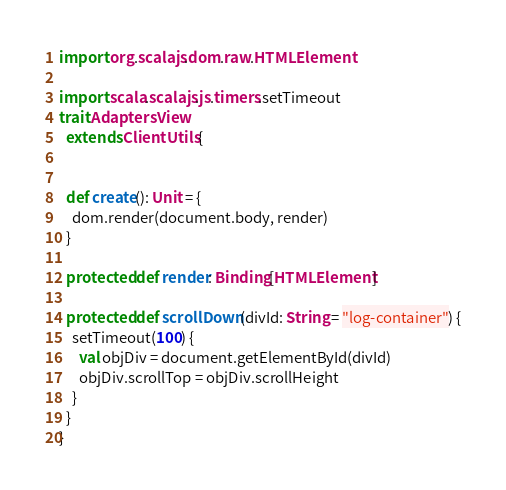Convert code to text. <code><loc_0><loc_0><loc_500><loc_500><_Scala_>import org.scalajs.dom.raw.HTMLElement

import scala.scalajs.js.timers.setTimeout
trait AdaptersView
  extends ClientUtils {


  def create(): Unit = {
    dom.render(document.body, render)
  }

  protected def render: Binding[HTMLElement]

  protected def scrollDown(divId: String = "log-container") {
    setTimeout(100) {
      val objDiv = document.getElementById(divId)
      objDiv.scrollTop = objDiv.scrollHeight
    }
  }
}
</code> 